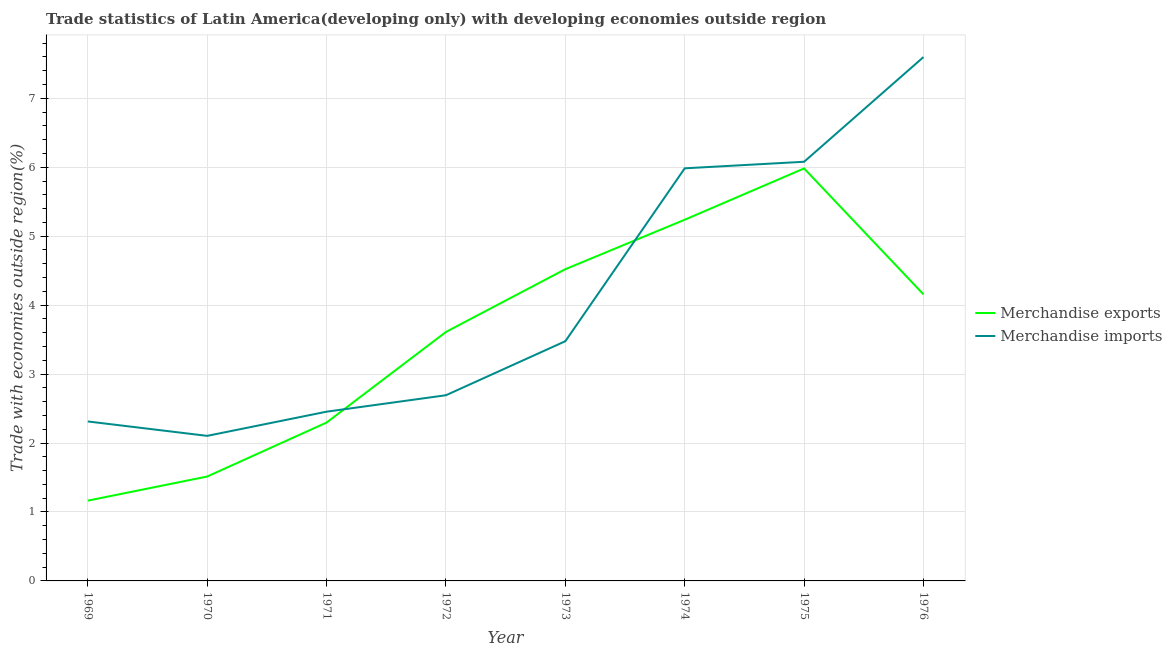Does the line corresponding to merchandise exports intersect with the line corresponding to merchandise imports?
Provide a short and direct response. Yes. What is the merchandise exports in 1973?
Give a very brief answer. 4.52. Across all years, what is the maximum merchandise imports?
Your answer should be compact. 7.6. Across all years, what is the minimum merchandise imports?
Provide a succinct answer. 2.1. In which year was the merchandise imports maximum?
Your response must be concise. 1976. In which year was the merchandise imports minimum?
Provide a short and direct response. 1970. What is the total merchandise exports in the graph?
Offer a very short reply. 28.49. What is the difference between the merchandise imports in 1974 and that in 1976?
Keep it short and to the point. -1.61. What is the difference between the merchandise exports in 1976 and the merchandise imports in 1970?
Provide a short and direct response. 2.05. What is the average merchandise imports per year?
Keep it short and to the point. 4.09. In the year 1969, what is the difference between the merchandise exports and merchandise imports?
Offer a terse response. -1.15. What is the ratio of the merchandise exports in 1971 to that in 1972?
Provide a short and direct response. 0.64. Is the difference between the merchandise exports in 1969 and 1974 greater than the difference between the merchandise imports in 1969 and 1974?
Keep it short and to the point. No. What is the difference between the highest and the second highest merchandise imports?
Offer a very short reply. 1.52. What is the difference between the highest and the lowest merchandise exports?
Your answer should be very brief. 4.82. Is the sum of the merchandise imports in 1970 and 1975 greater than the maximum merchandise exports across all years?
Your answer should be very brief. Yes. Does the merchandise imports monotonically increase over the years?
Your response must be concise. No. How many lines are there?
Your answer should be very brief. 2. What is the difference between two consecutive major ticks on the Y-axis?
Offer a terse response. 1. Does the graph contain grids?
Your answer should be compact. Yes. Where does the legend appear in the graph?
Your answer should be compact. Center right. How many legend labels are there?
Your answer should be very brief. 2. How are the legend labels stacked?
Provide a succinct answer. Vertical. What is the title of the graph?
Your answer should be compact. Trade statistics of Latin America(developing only) with developing economies outside region. Does "Diarrhea" appear as one of the legend labels in the graph?
Give a very brief answer. No. What is the label or title of the Y-axis?
Provide a succinct answer. Trade with economies outside region(%). What is the Trade with economies outside region(%) in Merchandise exports in 1969?
Make the answer very short. 1.16. What is the Trade with economies outside region(%) in Merchandise imports in 1969?
Ensure brevity in your answer.  2.31. What is the Trade with economies outside region(%) in Merchandise exports in 1970?
Keep it short and to the point. 1.51. What is the Trade with economies outside region(%) in Merchandise imports in 1970?
Ensure brevity in your answer.  2.1. What is the Trade with economies outside region(%) in Merchandise exports in 1971?
Ensure brevity in your answer.  2.3. What is the Trade with economies outside region(%) of Merchandise imports in 1971?
Provide a short and direct response. 2.45. What is the Trade with economies outside region(%) in Merchandise exports in 1972?
Offer a terse response. 3.61. What is the Trade with economies outside region(%) of Merchandise imports in 1972?
Ensure brevity in your answer.  2.69. What is the Trade with economies outside region(%) in Merchandise exports in 1973?
Your answer should be very brief. 4.52. What is the Trade with economies outside region(%) of Merchandise imports in 1973?
Your response must be concise. 3.48. What is the Trade with economies outside region(%) in Merchandise exports in 1974?
Keep it short and to the point. 5.24. What is the Trade with economies outside region(%) in Merchandise imports in 1974?
Make the answer very short. 5.98. What is the Trade with economies outside region(%) of Merchandise exports in 1975?
Ensure brevity in your answer.  5.98. What is the Trade with economies outside region(%) of Merchandise imports in 1975?
Give a very brief answer. 6.08. What is the Trade with economies outside region(%) in Merchandise exports in 1976?
Offer a terse response. 4.16. What is the Trade with economies outside region(%) of Merchandise imports in 1976?
Your answer should be very brief. 7.6. Across all years, what is the maximum Trade with economies outside region(%) of Merchandise exports?
Provide a short and direct response. 5.98. Across all years, what is the maximum Trade with economies outside region(%) of Merchandise imports?
Offer a terse response. 7.6. Across all years, what is the minimum Trade with economies outside region(%) in Merchandise exports?
Ensure brevity in your answer.  1.16. Across all years, what is the minimum Trade with economies outside region(%) of Merchandise imports?
Provide a short and direct response. 2.1. What is the total Trade with economies outside region(%) of Merchandise exports in the graph?
Make the answer very short. 28.49. What is the total Trade with economies outside region(%) of Merchandise imports in the graph?
Your response must be concise. 32.71. What is the difference between the Trade with economies outside region(%) in Merchandise exports in 1969 and that in 1970?
Provide a succinct answer. -0.35. What is the difference between the Trade with economies outside region(%) of Merchandise imports in 1969 and that in 1970?
Provide a succinct answer. 0.21. What is the difference between the Trade with economies outside region(%) in Merchandise exports in 1969 and that in 1971?
Ensure brevity in your answer.  -1.13. What is the difference between the Trade with economies outside region(%) in Merchandise imports in 1969 and that in 1971?
Ensure brevity in your answer.  -0.14. What is the difference between the Trade with economies outside region(%) in Merchandise exports in 1969 and that in 1972?
Ensure brevity in your answer.  -2.45. What is the difference between the Trade with economies outside region(%) of Merchandise imports in 1969 and that in 1972?
Your response must be concise. -0.38. What is the difference between the Trade with economies outside region(%) in Merchandise exports in 1969 and that in 1973?
Provide a short and direct response. -3.36. What is the difference between the Trade with economies outside region(%) in Merchandise imports in 1969 and that in 1973?
Offer a very short reply. -1.16. What is the difference between the Trade with economies outside region(%) in Merchandise exports in 1969 and that in 1974?
Your answer should be very brief. -4.07. What is the difference between the Trade with economies outside region(%) in Merchandise imports in 1969 and that in 1974?
Ensure brevity in your answer.  -3.67. What is the difference between the Trade with economies outside region(%) of Merchandise exports in 1969 and that in 1975?
Offer a very short reply. -4.82. What is the difference between the Trade with economies outside region(%) of Merchandise imports in 1969 and that in 1975?
Give a very brief answer. -3.77. What is the difference between the Trade with economies outside region(%) in Merchandise exports in 1969 and that in 1976?
Your answer should be compact. -2.99. What is the difference between the Trade with economies outside region(%) in Merchandise imports in 1969 and that in 1976?
Provide a succinct answer. -5.29. What is the difference between the Trade with economies outside region(%) of Merchandise exports in 1970 and that in 1971?
Provide a succinct answer. -0.78. What is the difference between the Trade with economies outside region(%) of Merchandise imports in 1970 and that in 1971?
Give a very brief answer. -0.35. What is the difference between the Trade with economies outside region(%) of Merchandise exports in 1970 and that in 1972?
Offer a terse response. -2.1. What is the difference between the Trade with economies outside region(%) of Merchandise imports in 1970 and that in 1972?
Keep it short and to the point. -0.59. What is the difference between the Trade with economies outside region(%) in Merchandise exports in 1970 and that in 1973?
Give a very brief answer. -3.01. What is the difference between the Trade with economies outside region(%) in Merchandise imports in 1970 and that in 1973?
Offer a terse response. -1.37. What is the difference between the Trade with economies outside region(%) in Merchandise exports in 1970 and that in 1974?
Your response must be concise. -3.72. What is the difference between the Trade with economies outside region(%) of Merchandise imports in 1970 and that in 1974?
Give a very brief answer. -3.88. What is the difference between the Trade with economies outside region(%) in Merchandise exports in 1970 and that in 1975?
Offer a terse response. -4.47. What is the difference between the Trade with economies outside region(%) in Merchandise imports in 1970 and that in 1975?
Provide a short and direct response. -3.98. What is the difference between the Trade with economies outside region(%) in Merchandise exports in 1970 and that in 1976?
Your answer should be very brief. -2.64. What is the difference between the Trade with economies outside region(%) of Merchandise imports in 1970 and that in 1976?
Provide a short and direct response. -5.49. What is the difference between the Trade with economies outside region(%) in Merchandise exports in 1971 and that in 1972?
Offer a very short reply. -1.31. What is the difference between the Trade with economies outside region(%) of Merchandise imports in 1971 and that in 1972?
Offer a terse response. -0.24. What is the difference between the Trade with economies outside region(%) of Merchandise exports in 1971 and that in 1973?
Your answer should be compact. -2.22. What is the difference between the Trade with economies outside region(%) of Merchandise imports in 1971 and that in 1973?
Give a very brief answer. -1.02. What is the difference between the Trade with economies outside region(%) of Merchandise exports in 1971 and that in 1974?
Ensure brevity in your answer.  -2.94. What is the difference between the Trade with economies outside region(%) of Merchandise imports in 1971 and that in 1974?
Offer a terse response. -3.53. What is the difference between the Trade with economies outside region(%) in Merchandise exports in 1971 and that in 1975?
Ensure brevity in your answer.  -3.69. What is the difference between the Trade with economies outside region(%) of Merchandise imports in 1971 and that in 1975?
Ensure brevity in your answer.  -3.62. What is the difference between the Trade with economies outside region(%) in Merchandise exports in 1971 and that in 1976?
Make the answer very short. -1.86. What is the difference between the Trade with economies outside region(%) of Merchandise imports in 1971 and that in 1976?
Provide a succinct answer. -5.14. What is the difference between the Trade with economies outside region(%) in Merchandise exports in 1972 and that in 1973?
Your answer should be very brief. -0.91. What is the difference between the Trade with economies outside region(%) of Merchandise imports in 1972 and that in 1973?
Your response must be concise. -0.78. What is the difference between the Trade with economies outside region(%) in Merchandise exports in 1972 and that in 1974?
Your answer should be compact. -1.63. What is the difference between the Trade with economies outside region(%) of Merchandise imports in 1972 and that in 1974?
Give a very brief answer. -3.29. What is the difference between the Trade with economies outside region(%) in Merchandise exports in 1972 and that in 1975?
Offer a very short reply. -2.37. What is the difference between the Trade with economies outside region(%) in Merchandise imports in 1972 and that in 1975?
Your answer should be compact. -3.39. What is the difference between the Trade with economies outside region(%) of Merchandise exports in 1972 and that in 1976?
Your answer should be very brief. -0.54. What is the difference between the Trade with economies outside region(%) in Merchandise imports in 1972 and that in 1976?
Offer a terse response. -4.91. What is the difference between the Trade with economies outside region(%) of Merchandise exports in 1973 and that in 1974?
Offer a terse response. -0.72. What is the difference between the Trade with economies outside region(%) in Merchandise imports in 1973 and that in 1974?
Your answer should be compact. -2.51. What is the difference between the Trade with economies outside region(%) in Merchandise exports in 1973 and that in 1975?
Ensure brevity in your answer.  -1.46. What is the difference between the Trade with economies outside region(%) of Merchandise imports in 1973 and that in 1975?
Your response must be concise. -2.6. What is the difference between the Trade with economies outside region(%) in Merchandise exports in 1973 and that in 1976?
Offer a terse response. 0.37. What is the difference between the Trade with economies outside region(%) in Merchandise imports in 1973 and that in 1976?
Provide a short and direct response. -4.12. What is the difference between the Trade with economies outside region(%) of Merchandise exports in 1974 and that in 1975?
Your response must be concise. -0.74. What is the difference between the Trade with economies outside region(%) of Merchandise imports in 1974 and that in 1975?
Give a very brief answer. -0.1. What is the difference between the Trade with economies outside region(%) of Merchandise exports in 1974 and that in 1976?
Make the answer very short. 1.08. What is the difference between the Trade with economies outside region(%) in Merchandise imports in 1974 and that in 1976?
Your answer should be very brief. -1.61. What is the difference between the Trade with economies outside region(%) of Merchandise exports in 1975 and that in 1976?
Keep it short and to the point. 1.83. What is the difference between the Trade with economies outside region(%) in Merchandise imports in 1975 and that in 1976?
Give a very brief answer. -1.52. What is the difference between the Trade with economies outside region(%) of Merchandise exports in 1969 and the Trade with economies outside region(%) of Merchandise imports in 1970?
Give a very brief answer. -0.94. What is the difference between the Trade with economies outside region(%) of Merchandise exports in 1969 and the Trade with economies outside region(%) of Merchandise imports in 1971?
Provide a succinct answer. -1.29. What is the difference between the Trade with economies outside region(%) in Merchandise exports in 1969 and the Trade with economies outside region(%) in Merchandise imports in 1972?
Your answer should be very brief. -1.53. What is the difference between the Trade with economies outside region(%) of Merchandise exports in 1969 and the Trade with economies outside region(%) of Merchandise imports in 1973?
Your response must be concise. -2.31. What is the difference between the Trade with economies outside region(%) of Merchandise exports in 1969 and the Trade with economies outside region(%) of Merchandise imports in 1974?
Keep it short and to the point. -4.82. What is the difference between the Trade with economies outside region(%) in Merchandise exports in 1969 and the Trade with economies outside region(%) in Merchandise imports in 1975?
Make the answer very short. -4.92. What is the difference between the Trade with economies outside region(%) in Merchandise exports in 1969 and the Trade with economies outside region(%) in Merchandise imports in 1976?
Provide a succinct answer. -6.43. What is the difference between the Trade with economies outside region(%) of Merchandise exports in 1970 and the Trade with economies outside region(%) of Merchandise imports in 1971?
Your answer should be very brief. -0.94. What is the difference between the Trade with economies outside region(%) in Merchandise exports in 1970 and the Trade with economies outside region(%) in Merchandise imports in 1972?
Keep it short and to the point. -1.18. What is the difference between the Trade with economies outside region(%) in Merchandise exports in 1970 and the Trade with economies outside region(%) in Merchandise imports in 1973?
Make the answer very short. -1.96. What is the difference between the Trade with economies outside region(%) in Merchandise exports in 1970 and the Trade with economies outside region(%) in Merchandise imports in 1974?
Your answer should be very brief. -4.47. What is the difference between the Trade with economies outside region(%) in Merchandise exports in 1970 and the Trade with economies outside region(%) in Merchandise imports in 1975?
Keep it short and to the point. -4.57. What is the difference between the Trade with economies outside region(%) in Merchandise exports in 1970 and the Trade with economies outside region(%) in Merchandise imports in 1976?
Offer a terse response. -6.08. What is the difference between the Trade with economies outside region(%) of Merchandise exports in 1971 and the Trade with economies outside region(%) of Merchandise imports in 1972?
Your answer should be very brief. -0.4. What is the difference between the Trade with economies outside region(%) of Merchandise exports in 1971 and the Trade with economies outside region(%) of Merchandise imports in 1973?
Offer a terse response. -1.18. What is the difference between the Trade with economies outside region(%) in Merchandise exports in 1971 and the Trade with economies outside region(%) in Merchandise imports in 1974?
Your answer should be very brief. -3.69. What is the difference between the Trade with economies outside region(%) of Merchandise exports in 1971 and the Trade with economies outside region(%) of Merchandise imports in 1975?
Offer a terse response. -3.78. What is the difference between the Trade with economies outside region(%) of Merchandise exports in 1971 and the Trade with economies outside region(%) of Merchandise imports in 1976?
Your response must be concise. -5.3. What is the difference between the Trade with economies outside region(%) of Merchandise exports in 1972 and the Trade with economies outside region(%) of Merchandise imports in 1973?
Give a very brief answer. 0.13. What is the difference between the Trade with economies outside region(%) in Merchandise exports in 1972 and the Trade with economies outside region(%) in Merchandise imports in 1974?
Make the answer very short. -2.37. What is the difference between the Trade with economies outside region(%) in Merchandise exports in 1972 and the Trade with economies outside region(%) in Merchandise imports in 1975?
Ensure brevity in your answer.  -2.47. What is the difference between the Trade with economies outside region(%) in Merchandise exports in 1972 and the Trade with economies outside region(%) in Merchandise imports in 1976?
Offer a very short reply. -3.99. What is the difference between the Trade with economies outside region(%) in Merchandise exports in 1973 and the Trade with economies outside region(%) in Merchandise imports in 1974?
Your answer should be very brief. -1.46. What is the difference between the Trade with economies outside region(%) of Merchandise exports in 1973 and the Trade with economies outside region(%) of Merchandise imports in 1975?
Ensure brevity in your answer.  -1.56. What is the difference between the Trade with economies outside region(%) of Merchandise exports in 1973 and the Trade with economies outside region(%) of Merchandise imports in 1976?
Your answer should be very brief. -3.08. What is the difference between the Trade with economies outside region(%) in Merchandise exports in 1974 and the Trade with economies outside region(%) in Merchandise imports in 1975?
Offer a terse response. -0.84. What is the difference between the Trade with economies outside region(%) in Merchandise exports in 1974 and the Trade with economies outside region(%) in Merchandise imports in 1976?
Offer a terse response. -2.36. What is the difference between the Trade with economies outside region(%) in Merchandise exports in 1975 and the Trade with economies outside region(%) in Merchandise imports in 1976?
Your answer should be very brief. -1.62. What is the average Trade with economies outside region(%) of Merchandise exports per year?
Make the answer very short. 3.56. What is the average Trade with economies outside region(%) of Merchandise imports per year?
Your answer should be compact. 4.09. In the year 1969, what is the difference between the Trade with economies outside region(%) of Merchandise exports and Trade with economies outside region(%) of Merchandise imports?
Make the answer very short. -1.15. In the year 1970, what is the difference between the Trade with economies outside region(%) in Merchandise exports and Trade with economies outside region(%) in Merchandise imports?
Provide a succinct answer. -0.59. In the year 1971, what is the difference between the Trade with economies outside region(%) of Merchandise exports and Trade with economies outside region(%) of Merchandise imports?
Your answer should be very brief. -0.16. In the year 1972, what is the difference between the Trade with economies outside region(%) of Merchandise exports and Trade with economies outside region(%) of Merchandise imports?
Offer a terse response. 0.92. In the year 1973, what is the difference between the Trade with economies outside region(%) of Merchandise exports and Trade with economies outside region(%) of Merchandise imports?
Make the answer very short. 1.04. In the year 1974, what is the difference between the Trade with economies outside region(%) in Merchandise exports and Trade with economies outside region(%) in Merchandise imports?
Give a very brief answer. -0.75. In the year 1975, what is the difference between the Trade with economies outside region(%) of Merchandise exports and Trade with economies outside region(%) of Merchandise imports?
Make the answer very short. -0.1. In the year 1976, what is the difference between the Trade with economies outside region(%) of Merchandise exports and Trade with economies outside region(%) of Merchandise imports?
Keep it short and to the point. -3.44. What is the ratio of the Trade with economies outside region(%) of Merchandise exports in 1969 to that in 1970?
Offer a terse response. 0.77. What is the ratio of the Trade with economies outside region(%) of Merchandise imports in 1969 to that in 1970?
Give a very brief answer. 1.1. What is the ratio of the Trade with economies outside region(%) in Merchandise exports in 1969 to that in 1971?
Offer a very short reply. 0.51. What is the ratio of the Trade with economies outside region(%) in Merchandise imports in 1969 to that in 1971?
Your response must be concise. 0.94. What is the ratio of the Trade with economies outside region(%) in Merchandise exports in 1969 to that in 1972?
Offer a very short reply. 0.32. What is the ratio of the Trade with economies outside region(%) of Merchandise imports in 1969 to that in 1972?
Provide a succinct answer. 0.86. What is the ratio of the Trade with economies outside region(%) of Merchandise exports in 1969 to that in 1973?
Make the answer very short. 0.26. What is the ratio of the Trade with economies outside region(%) of Merchandise imports in 1969 to that in 1973?
Provide a succinct answer. 0.67. What is the ratio of the Trade with economies outside region(%) of Merchandise exports in 1969 to that in 1974?
Keep it short and to the point. 0.22. What is the ratio of the Trade with economies outside region(%) in Merchandise imports in 1969 to that in 1974?
Provide a succinct answer. 0.39. What is the ratio of the Trade with economies outside region(%) in Merchandise exports in 1969 to that in 1975?
Offer a very short reply. 0.19. What is the ratio of the Trade with economies outside region(%) in Merchandise imports in 1969 to that in 1975?
Give a very brief answer. 0.38. What is the ratio of the Trade with economies outside region(%) in Merchandise exports in 1969 to that in 1976?
Provide a short and direct response. 0.28. What is the ratio of the Trade with economies outside region(%) in Merchandise imports in 1969 to that in 1976?
Make the answer very short. 0.3. What is the ratio of the Trade with economies outside region(%) in Merchandise exports in 1970 to that in 1971?
Offer a terse response. 0.66. What is the ratio of the Trade with economies outside region(%) of Merchandise imports in 1970 to that in 1971?
Your answer should be compact. 0.86. What is the ratio of the Trade with economies outside region(%) in Merchandise exports in 1970 to that in 1972?
Your answer should be compact. 0.42. What is the ratio of the Trade with economies outside region(%) of Merchandise imports in 1970 to that in 1972?
Your answer should be compact. 0.78. What is the ratio of the Trade with economies outside region(%) of Merchandise exports in 1970 to that in 1973?
Make the answer very short. 0.33. What is the ratio of the Trade with economies outside region(%) of Merchandise imports in 1970 to that in 1973?
Keep it short and to the point. 0.61. What is the ratio of the Trade with economies outside region(%) of Merchandise exports in 1970 to that in 1974?
Provide a succinct answer. 0.29. What is the ratio of the Trade with economies outside region(%) of Merchandise imports in 1970 to that in 1974?
Your response must be concise. 0.35. What is the ratio of the Trade with economies outside region(%) in Merchandise exports in 1970 to that in 1975?
Make the answer very short. 0.25. What is the ratio of the Trade with economies outside region(%) of Merchandise imports in 1970 to that in 1975?
Offer a terse response. 0.35. What is the ratio of the Trade with economies outside region(%) in Merchandise exports in 1970 to that in 1976?
Keep it short and to the point. 0.36. What is the ratio of the Trade with economies outside region(%) in Merchandise imports in 1970 to that in 1976?
Keep it short and to the point. 0.28. What is the ratio of the Trade with economies outside region(%) of Merchandise exports in 1971 to that in 1972?
Offer a terse response. 0.64. What is the ratio of the Trade with economies outside region(%) in Merchandise imports in 1971 to that in 1972?
Your answer should be compact. 0.91. What is the ratio of the Trade with economies outside region(%) of Merchandise exports in 1971 to that in 1973?
Your response must be concise. 0.51. What is the ratio of the Trade with economies outside region(%) in Merchandise imports in 1971 to that in 1973?
Provide a succinct answer. 0.71. What is the ratio of the Trade with economies outside region(%) of Merchandise exports in 1971 to that in 1974?
Offer a terse response. 0.44. What is the ratio of the Trade with economies outside region(%) in Merchandise imports in 1971 to that in 1974?
Offer a very short reply. 0.41. What is the ratio of the Trade with economies outside region(%) in Merchandise exports in 1971 to that in 1975?
Your answer should be compact. 0.38. What is the ratio of the Trade with economies outside region(%) of Merchandise imports in 1971 to that in 1975?
Your response must be concise. 0.4. What is the ratio of the Trade with economies outside region(%) in Merchandise exports in 1971 to that in 1976?
Ensure brevity in your answer.  0.55. What is the ratio of the Trade with economies outside region(%) in Merchandise imports in 1971 to that in 1976?
Your answer should be compact. 0.32. What is the ratio of the Trade with economies outside region(%) of Merchandise exports in 1972 to that in 1973?
Provide a short and direct response. 0.8. What is the ratio of the Trade with economies outside region(%) of Merchandise imports in 1972 to that in 1973?
Provide a succinct answer. 0.77. What is the ratio of the Trade with economies outside region(%) of Merchandise exports in 1972 to that in 1974?
Keep it short and to the point. 0.69. What is the ratio of the Trade with economies outside region(%) of Merchandise imports in 1972 to that in 1974?
Offer a very short reply. 0.45. What is the ratio of the Trade with economies outside region(%) in Merchandise exports in 1972 to that in 1975?
Give a very brief answer. 0.6. What is the ratio of the Trade with economies outside region(%) of Merchandise imports in 1972 to that in 1975?
Give a very brief answer. 0.44. What is the ratio of the Trade with economies outside region(%) of Merchandise exports in 1972 to that in 1976?
Your response must be concise. 0.87. What is the ratio of the Trade with economies outside region(%) in Merchandise imports in 1972 to that in 1976?
Offer a very short reply. 0.35. What is the ratio of the Trade with economies outside region(%) in Merchandise exports in 1973 to that in 1974?
Your response must be concise. 0.86. What is the ratio of the Trade with economies outside region(%) in Merchandise imports in 1973 to that in 1974?
Your answer should be compact. 0.58. What is the ratio of the Trade with economies outside region(%) in Merchandise exports in 1973 to that in 1975?
Make the answer very short. 0.76. What is the ratio of the Trade with economies outside region(%) in Merchandise imports in 1973 to that in 1975?
Keep it short and to the point. 0.57. What is the ratio of the Trade with economies outside region(%) in Merchandise exports in 1973 to that in 1976?
Offer a very short reply. 1.09. What is the ratio of the Trade with economies outside region(%) of Merchandise imports in 1973 to that in 1976?
Keep it short and to the point. 0.46. What is the ratio of the Trade with economies outside region(%) in Merchandise exports in 1974 to that in 1975?
Make the answer very short. 0.88. What is the ratio of the Trade with economies outside region(%) of Merchandise imports in 1974 to that in 1975?
Keep it short and to the point. 0.98. What is the ratio of the Trade with economies outside region(%) in Merchandise exports in 1974 to that in 1976?
Your answer should be very brief. 1.26. What is the ratio of the Trade with economies outside region(%) in Merchandise imports in 1974 to that in 1976?
Keep it short and to the point. 0.79. What is the ratio of the Trade with economies outside region(%) in Merchandise exports in 1975 to that in 1976?
Give a very brief answer. 1.44. What is the ratio of the Trade with economies outside region(%) in Merchandise imports in 1975 to that in 1976?
Offer a very short reply. 0.8. What is the difference between the highest and the second highest Trade with economies outside region(%) of Merchandise exports?
Ensure brevity in your answer.  0.74. What is the difference between the highest and the second highest Trade with economies outside region(%) of Merchandise imports?
Make the answer very short. 1.52. What is the difference between the highest and the lowest Trade with economies outside region(%) of Merchandise exports?
Ensure brevity in your answer.  4.82. What is the difference between the highest and the lowest Trade with economies outside region(%) of Merchandise imports?
Your answer should be very brief. 5.49. 